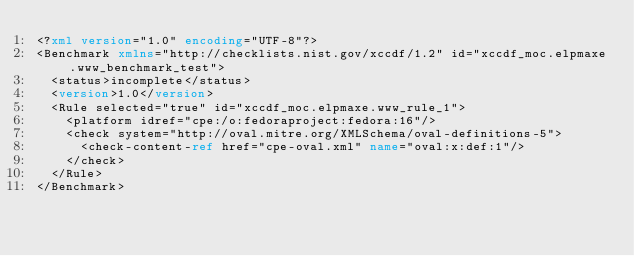<code> <loc_0><loc_0><loc_500><loc_500><_XML_><?xml version="1.0" encoding="UTF-8"?>
<Benchmark xmlns="http://checklists.nist.gov/xccdf/1.2" id="xccdf_moc.elpmaxe.www_benchmark_test">
  <status>incomplete</status>
  <version>1.0</version>
  <Rule selected="true" id="xccdf_moc.elpmaxe.www_rule_1">
    <platform idref="cpe:/o:fedoraproject:fedora:16"/>
    <check system="http://oval.mitre.org/XMLSchema/oval-definitions-5">
      <check-content-ref href="cpe-oval.xml" name="oval:x:def:1"/>
    </check>
  </Rule>
</Benchmark>
</code> 